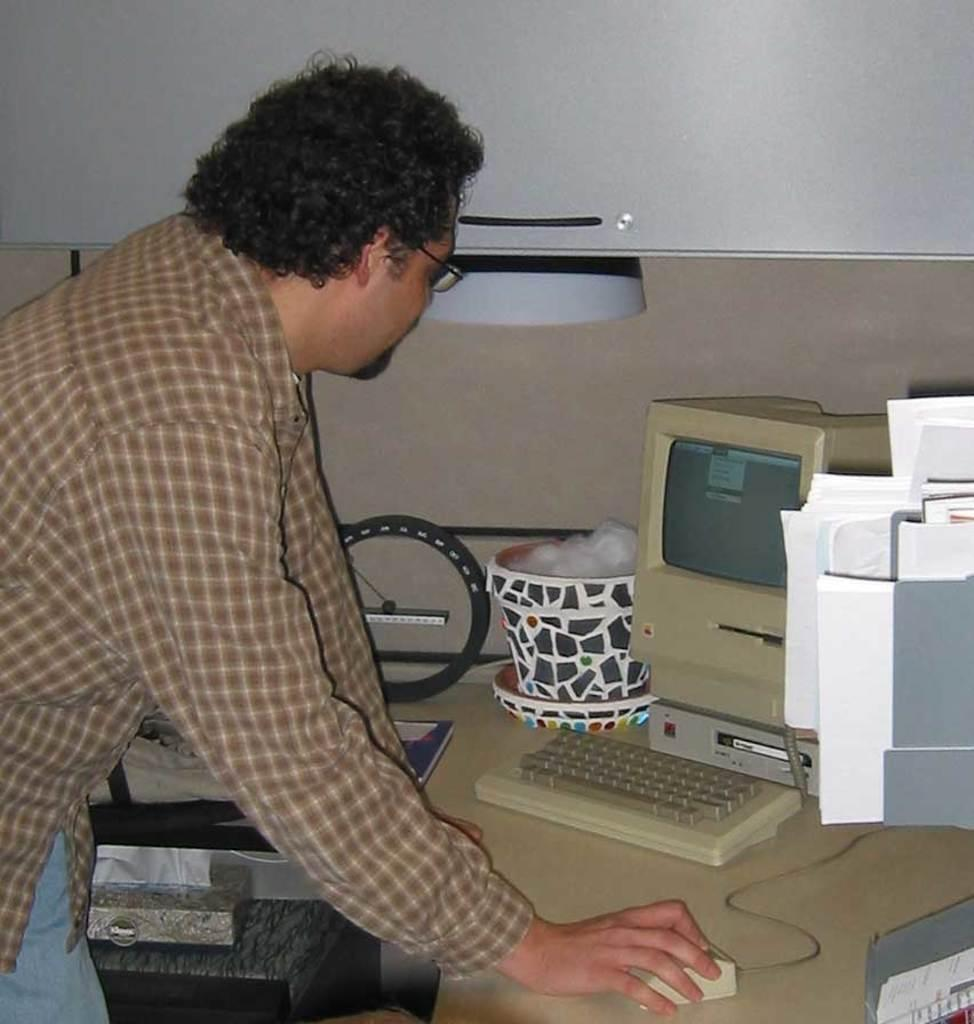What is the main subject of the image? The main subject of the image is a man. What is the man doing in the image? The man is standing and using a mouse. Where is the mouse located in the image? The mouse is on a table. What is in front of the man in the image? There is a computer in front of the man. What other objects can be seen on the table in the image? There are files, a cup, a back (possibly a chair back), and a keyboard on the table. What type of loaf is sitting on the table in the image? There is no loaf present in the image. How many pets can be seen in the image? There are no pets visible in the image. 